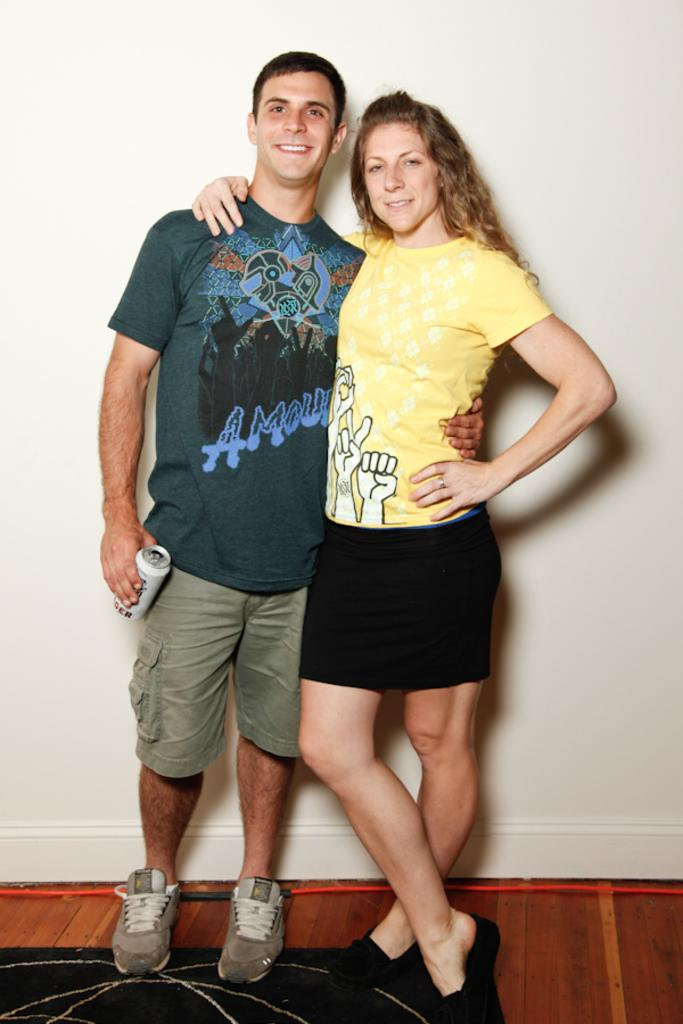What is the man in the image holding? The man is holding a tin in the image. Who else is present in the image? There is a woman in the image. What are the man and woman doing in the image? They are standing and posing for a photo. What can be seen in the background of the image? There is a wall in the background of the image. What type of rhythm can be heard in the image? There is no sound or music present in the image, so it is not possible to determine the rhythm. 